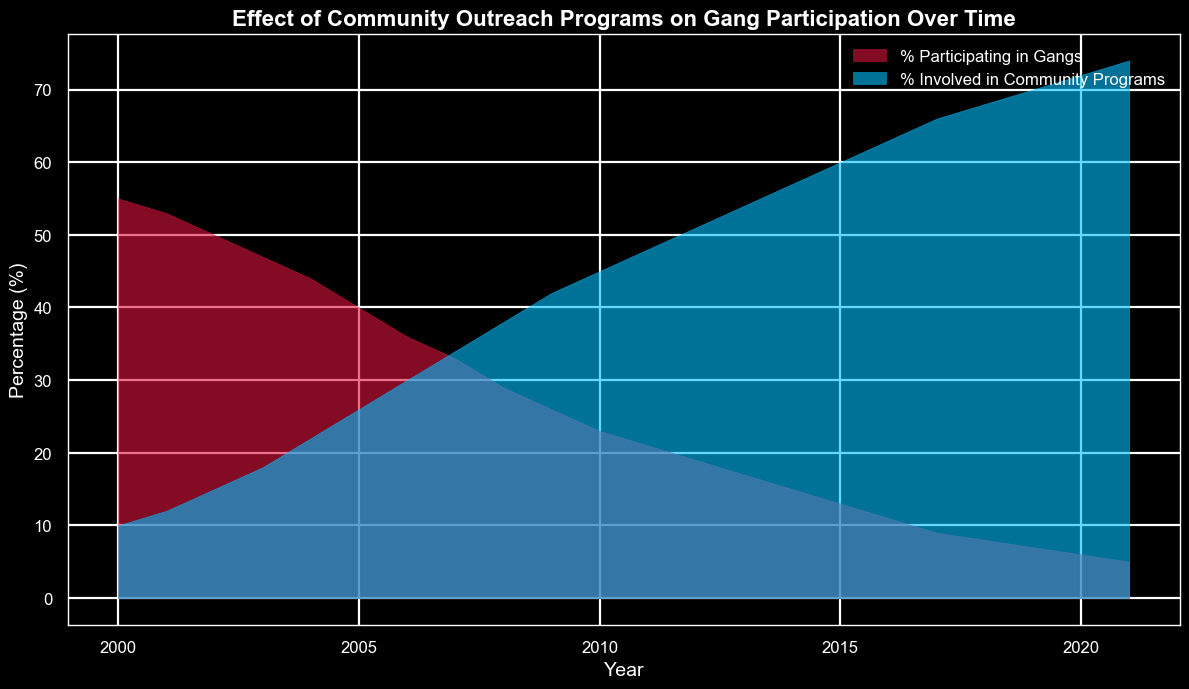What percentage of people were participating in gangs in 2000 compared to those involved in community programs? In 2000, the chart shows 55% of people were participating in gangs and 10% were involved in community programs.
Answer: 55% for gangs, 10% for community programs Between which years did the participation in gangs decrease the most? From the chart, the participation in gangs decreased from 55% in 2000 to 21% in 2011, a difference of 34%. The decrease is consistent year by year, but the largest annual drop is about 4% between 2004 and 2005 (from 44% to 40%).
Answer: 2004-2005 By how many percentage points did the involvement in community programs increase from 2000 to 2021? In 2000, the percentage involved in community programs was 10%, and in 2021 it was 74%. The increase is 74 - 10 = 64 percentage points.
Answer: 64 percentage points Which year had a larger percentage of the population involved in community programs than participating in gangs for the first time? Observing the chart, in 2011, the percentage involved in community programs is 48%, which surpasses the 21% participating in gangs for the first time.
Answer: 2011 What was the trend in gang participation and community program involvement from 2000 to 2021? From the chart, gang participation consistently decreased from 55% in 2000 to 5% in 2021, while community program involvement increased consistently from 10% in 2000 to 74% in 2021.
Answer: Gang participation decreased, community involvement increased How did community program involvement change from 2002 to 2006? In 2002, involvement was 15%. By 2006, it increased to 30%. The change is 30 - 15 = 15 percentage points.
Answer: Increased by 15 percentage points In which year did the community program involvement reach 60%? According to the chart, the involvement in community programs reached 60% in 2015.
Answer: 2015 What is the difference in percentages of gang participation and community involvement in 2020? In 2020, the percentage of gang participation is 6%, and the percentage of community program involvement is 72%. The difference is 72 - 6 = 66 percentage points.
Answer: 66 percentage points How does the area (colored) representing gang participation compare to that representing community programs from 2000 to 2021 visually? Visually, the red area representing gang participation continuously shrinks, while the blue area representing community programs steadily expands, indicating a significant shift over time.
Answer: Gang participation shrinks, community programs expand 